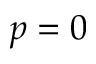Convert formula to latex. <formula><loc_0><loc_0><loc_500><loc_500>p = 0</formula> 